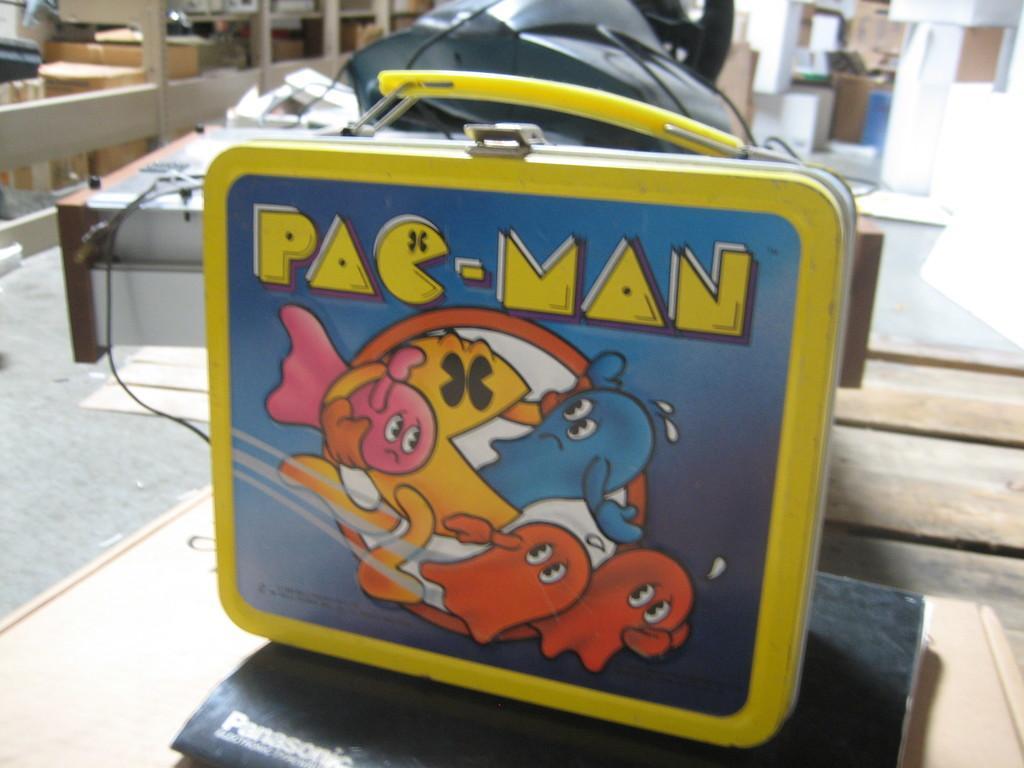Could you give a brief overview of what you see in this image? In this picture we can see a box on the book and the book is on the surface. Behind the box, there are some objects, a cable and a blurred background. 